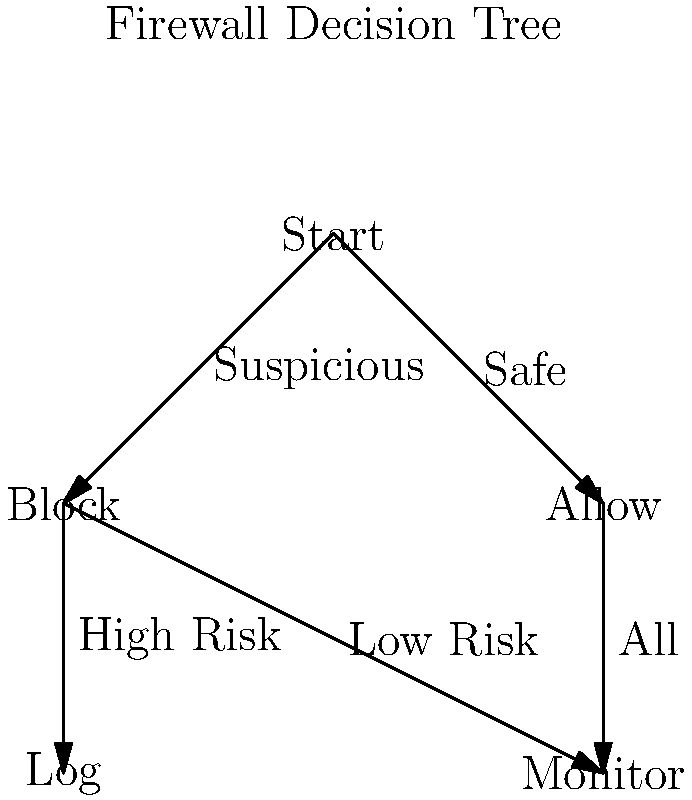A company's firewall uses the decision tree shown above to process incoming network traffic. If 60% of traffic is initially classified as safe, 25% of suspicious traffic is deemed low risk, and all safe traffic is monitored, what percentage of total traffic is monitored? Let's break this down step-by-step:

1) First, we need to identify the paths that lead to monitoring:
   - Safe traffic is always monitored (right branch)
   - Suspicious traffic that is low risk is monitored (middle branch)

2) We're given that 60% of traffic is classified as safe. This means:
   - 60% of traffic is safe
   - 40% of traffic is suspicious (100% - 60% = 40%)

3) Of the suspicious traffic, 25% is deemed low risk. This means:
   - 25% of 40% = 0.25 * 40% = 10% of total traffic is suspicious and low risk

4) Now, let's sum up the monitored traffic:
   - All safe traffic: 60%
   - Suspicious and low risk traffic: 10%

5) Total monitored traffic:
   $60\% + 10\% = 70\%$

Therefore, 70% of total traffic is monitored.
Answer: 70% 